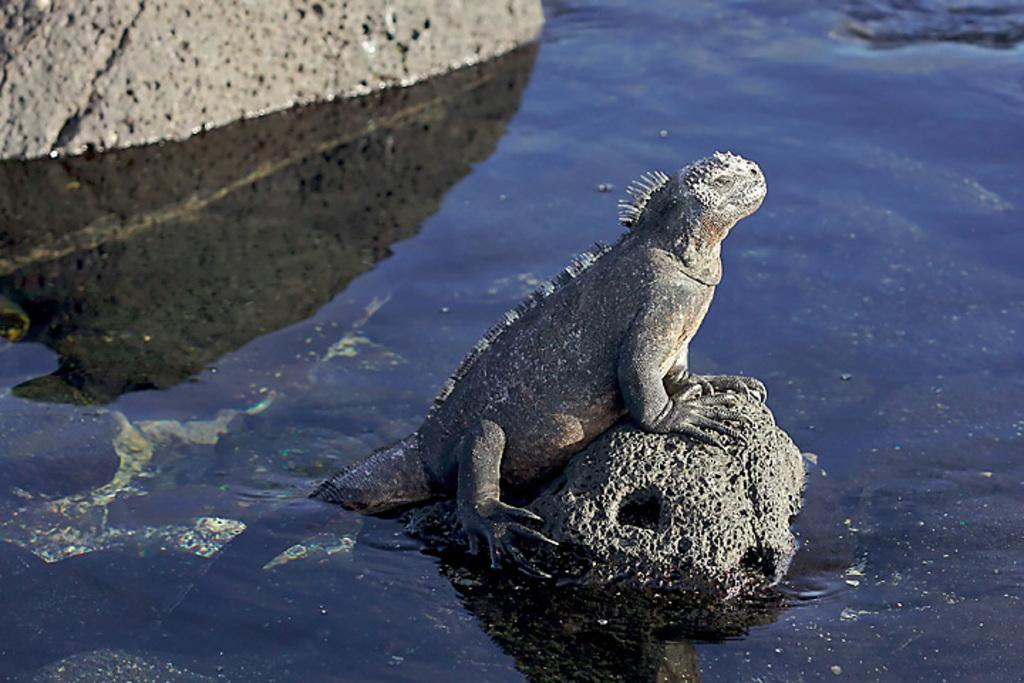What type of animal is in the image? There is an iguana in the image. What is the iguana standing on? The iguana is standing on a car. Where is the car located? The car is in the middle of a lake. How many tomatoes can be seen in the image? There are no tomatoes present in the image. What is the iguana thinking about in the image? It is impossible to determine what the iguana is thinking about from the image. 